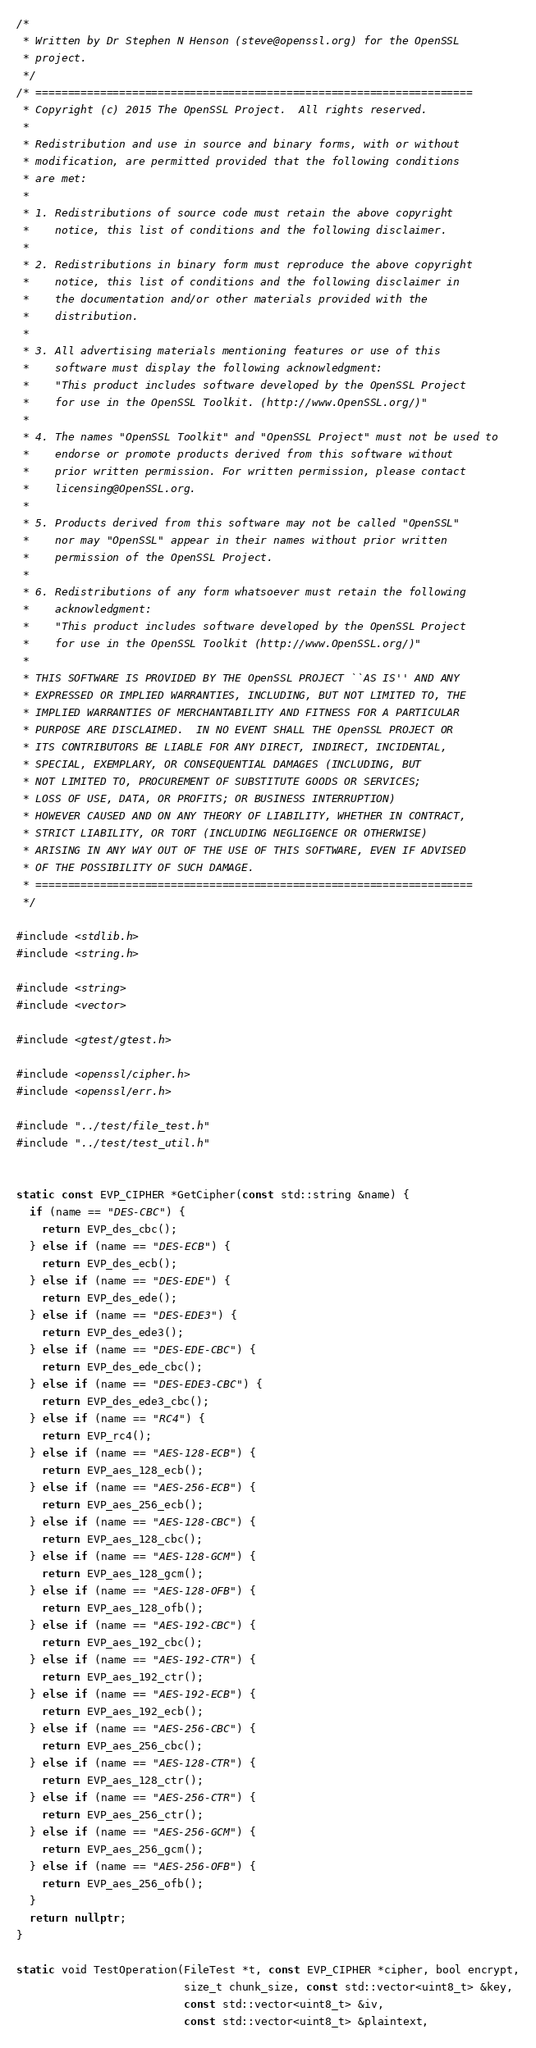<code> <loc_0><loc_0><loc_500><loc_500><_C++_>/*
 * Written by Dr Stephen N Henson (steve@openssl.org) for the OpenSSL
 * project.
 */
/* ====================================================================
 * Copyright (c) 2015 The OpenSSL Project.  All rights reserved.
 *
 * Redistribution and use in source and binary forms, with or without
 * modification, are permitted provided that the following conditions
 * are met:
 *
 * 1. Redistributions of source code must retain the above copyright
 *    notice, this list of conditions and the following disclaimer.
 *
 * 2. Redistributions in binary form must reproduce the above copyright
 *    notice, this list of conditions and the following disclaimer in
 *    the documentation and/or other materials provided with the
 *    distribution.
 *
 * 3. All advertising materials mentioning features or use of this
 *    software must display the following acknowledgment:
 *    "This product includes software developed by the OpenSSL Project
 *    for use in the OpenSSL Toolkit. (http://www.OpenSSL.org/)"
 *
 * 4. The names "OpenSSL Toolkit" and "OpenSSL Project" must not be used to
 *    endorse or promote products derived from this software without
 *    prior written permission. For written permission, please contact
 *    licensing@OpenSSL.org.
 *
 * 5. Products derived from this software may not be called "OpenSSL"
 *    nor may "OpenSSL" appear in their names without prior written
 *    permission of the OpenSSL Project.
 *
 * 6. Redistributions of any form whatsoever must retain the following
 *    acknowledgment:
 *    "This product includes software developed by the OpenSSL Project
 *    for use in the OpenSSL Toolkit (http://www.OpenSSL.org/)"
 *
 * THIS SOFTWARE IS PROVIDED BY THE OpenSSL PROJECT ``AS IS'' AND ANY
 * EXPRESSED OR IMPLIED WARRANTIES, INCLUDING, BUT NOT LIMITED TO, THE
 * IMPLIED WARRANTIES OF MERCHANTABILITY AND FITNESS FOR A PARTICULAR
 * PURPOSE ARE DISCLAIMED.  IN NO EVENT SHALL THE OpenSSL PROJECT OR
 * ITS CONTRIBUTORS BE LIABLE FOR ANY DIRECT, INDIRECT, INCIDENTAL,
 * SPECIAL, EXEMPLARY, OR CONSEQUENTIAL DAMAGES (INCLUDING, BUT
 * NOT LIMITED TO, PROCUREMENT OF SUBSTITUTE GOODS OR SERVICES;
 * LOSS OF USE, DATA, OR PROFITS; OR BUSINESS INTERRUPTION)
 * HOWEVER CAUSED AND ON ANY THEORY OF LIABILITY, WHETHER IN CONTRACT,
 * STRICT LIABILITY, OR TORT (INCLUDING NEGLIGENCE OR OTHERWISE)
 * ARISING IN ANY WAY OUT OF THE USE OF THIS SOFTWARE, EVEN IF ADVISED
 * OF THE POSSIBILITY OF SUCH DAMAGE.
 * ====================================================================
 */

#include <stdlib.h>
#include <string.h>

#include <string>
#include <vector>

#include <gtest/gtest.h>

#include <openssl/cipher.h>
#include <openssl/err.h>

#include "../test/file_test.h"
#include "../test/test_util.h"


static const EVP_CIPHER *GetCipher(const std::string &name) {
  if (name == "DES-CBC") {
    return EVP_des_cbc();
  } else if (name == "DES-ECB") {
    return EVP_des_ecb();
  } else if (name == "DES-EDE") {
    return EVP_des_ede();
  } else if (name == "DES-EDE3") {
    return EVP_des_ede3();
  } else if (name == "DES-EDE-CBC") {
    return EVP_des_ede_cbc();
  } else if (name == "DES-EDE3-CBC") {
    return EVP_des_ede3_cbc();
  } else if (name == "RC4") {
    return EVP_rc4();
  } else if (name == "AES-128-ECB") {
    return EVP_aes_128_ecb();
  } else if (name == "AES-256-ECB") {
    return EVP_aes_256_ecb();
  } else if (name == "AES-128-CBC") {
    return EVP_aes_128_cbc();
  } else if (name == "AES-128-GCM") {
    return EVP_aes_128_gcm();
  } else if (name == "AES-128-OFB") {
    return EVP_aes_128_ofb();
  } else if (name == "AES-192-CBC") {
    return EVP_aes_192_cbc();
  } else if (name == "AES-192-CTR") {
    return EVP_aes_192_ctr();
  } else if (name == "AES-192-ECB") {
    return EVP_aes_192_ecb();
  } else if (name == "AES-256-CBC") {
    return EVP_aes_256_cbc();
  } else if (name == "AES-128-CTR") {
    return EVP_aes_128_ctr();
  } else if (name == "AES-256-CTR") {
    return EVP_aes_256_ctr();
  } else if (name == "AES-256-GCM") {
    return EVP_aes_256_gcm();
  } else if (name == "AES-256-OFB") {
    return EVP_aes_256_ofb();
  }
  return nullptr;
}

static void TestOperation(FileTest *t, const EVP_CIPHER *cipher, bool encrypt,
                          size_t chunk_size, const std::vector<uint8_t> &key,
                          const std::vector<uint8_t> &iv,
                          const std::vector<uint8_t> &plaintext,</code> 